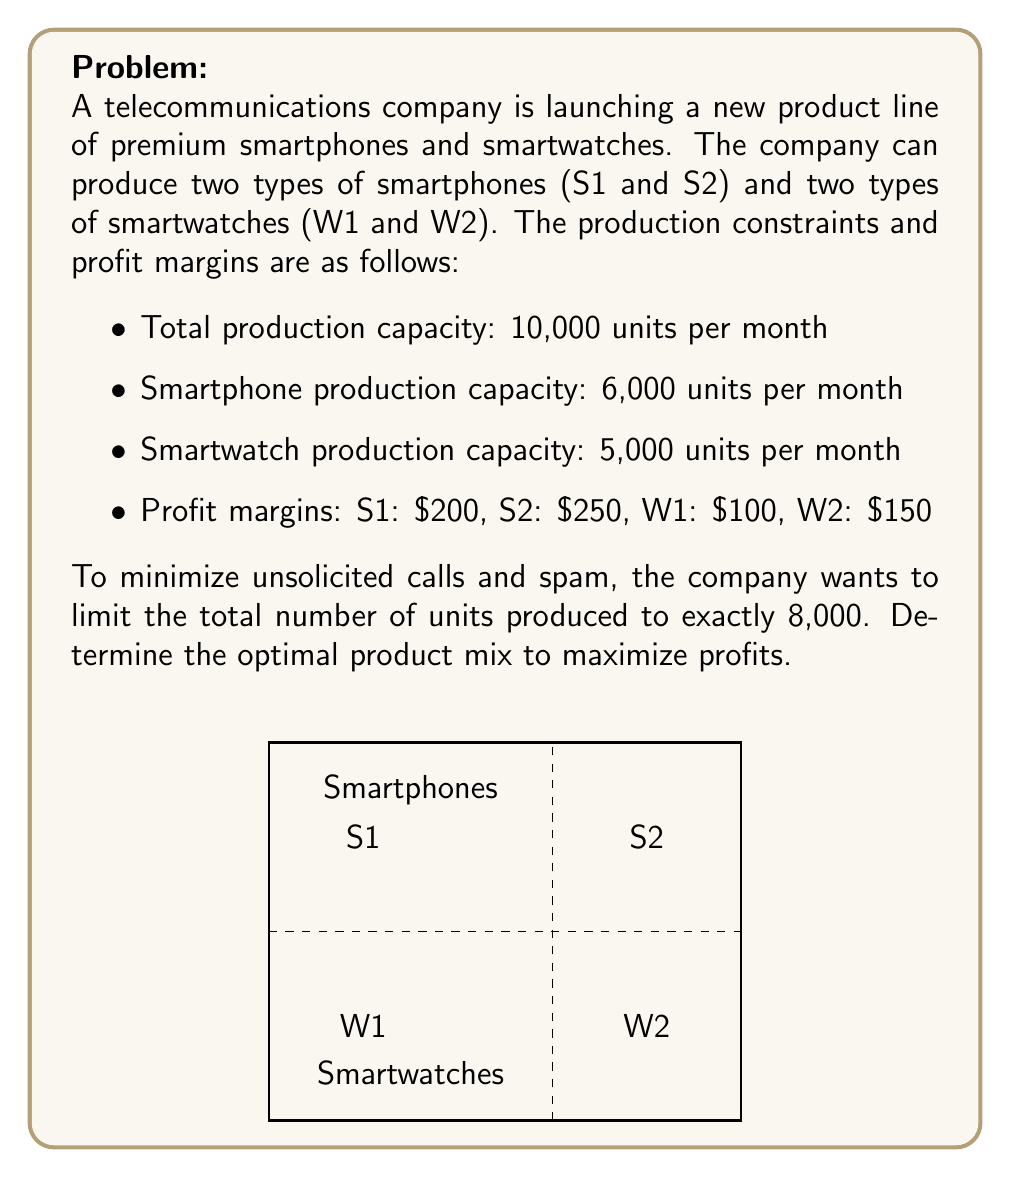Can you answer this question? Let's solve this problem step by step using linear programming:

1) Define variables:
   Let $x_1$, $x_2$, $x_3$, and $x_4$ be the number of units produced for S1, S2, W1, and W2 respectively.

2) Objective function:
   Maximize $Z = 200x_1 + 250x_2 + 100x_3 + 150x_4$

3) Constraints:
   a) Total production: $x_1 + x_2 + x_3 + x_4 = 8000$
   b) Smartphone capacity: $x_1 + x_2 \leq 6000$
   c) Smartwatch capacity: $x_3 + x_4 \leq 5000$
   d) Non-negativity: $x_1, x_2, x_3, x_4 \geq 0$

4) Solving:
   - From constraint (a), we know that smartwatches will take up 2000 to 5000 units.
   - S2 has a higher profit margin than S1, so we should maximize S2 production.
   - W2 has a higher profit margin than W1, so we should maximize W2 production.

5) Optimal solution:
   - Produce 6000 S2 (maximum smartphone capacity)
   - Produce 2000 W2 (to reach the total of 8000 units)

6) Profit calculation:
   $Z = 250 * 6000 + 150 * 2000 = 1,500,000 + 300,000 = 1,800,000$

Therefore, the optimal product mix is 6000 units of S2 and 2000 units of W2, yielding a maximum profit of $1,800,000.
Answer: 6000 S2, 2000 W2; $1,800,000 profit 